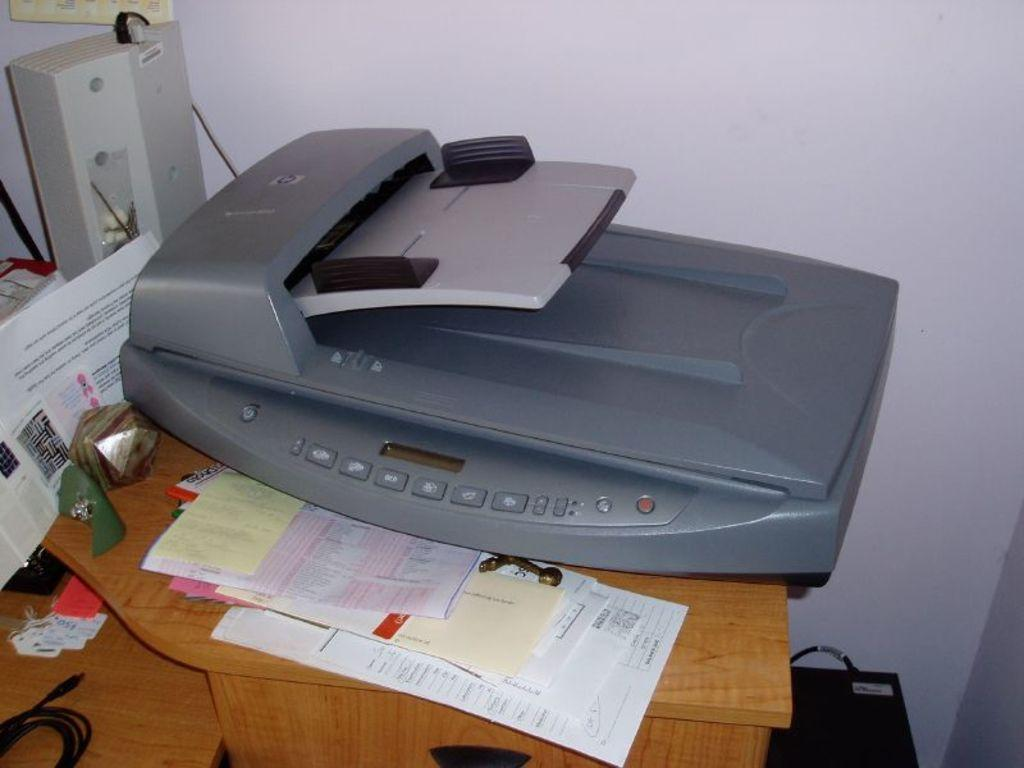What piece of furniture is visible in the image? There is a table in the image. What items can be seen on the table? Papers and a scanner are present on the table. What can be seen in the background of the image? There is a wall in the background of the image. What type of neck accessory is hanging from the wall in the image? There is no neck accessory present in the image; the wall is the only background element mentioned. 